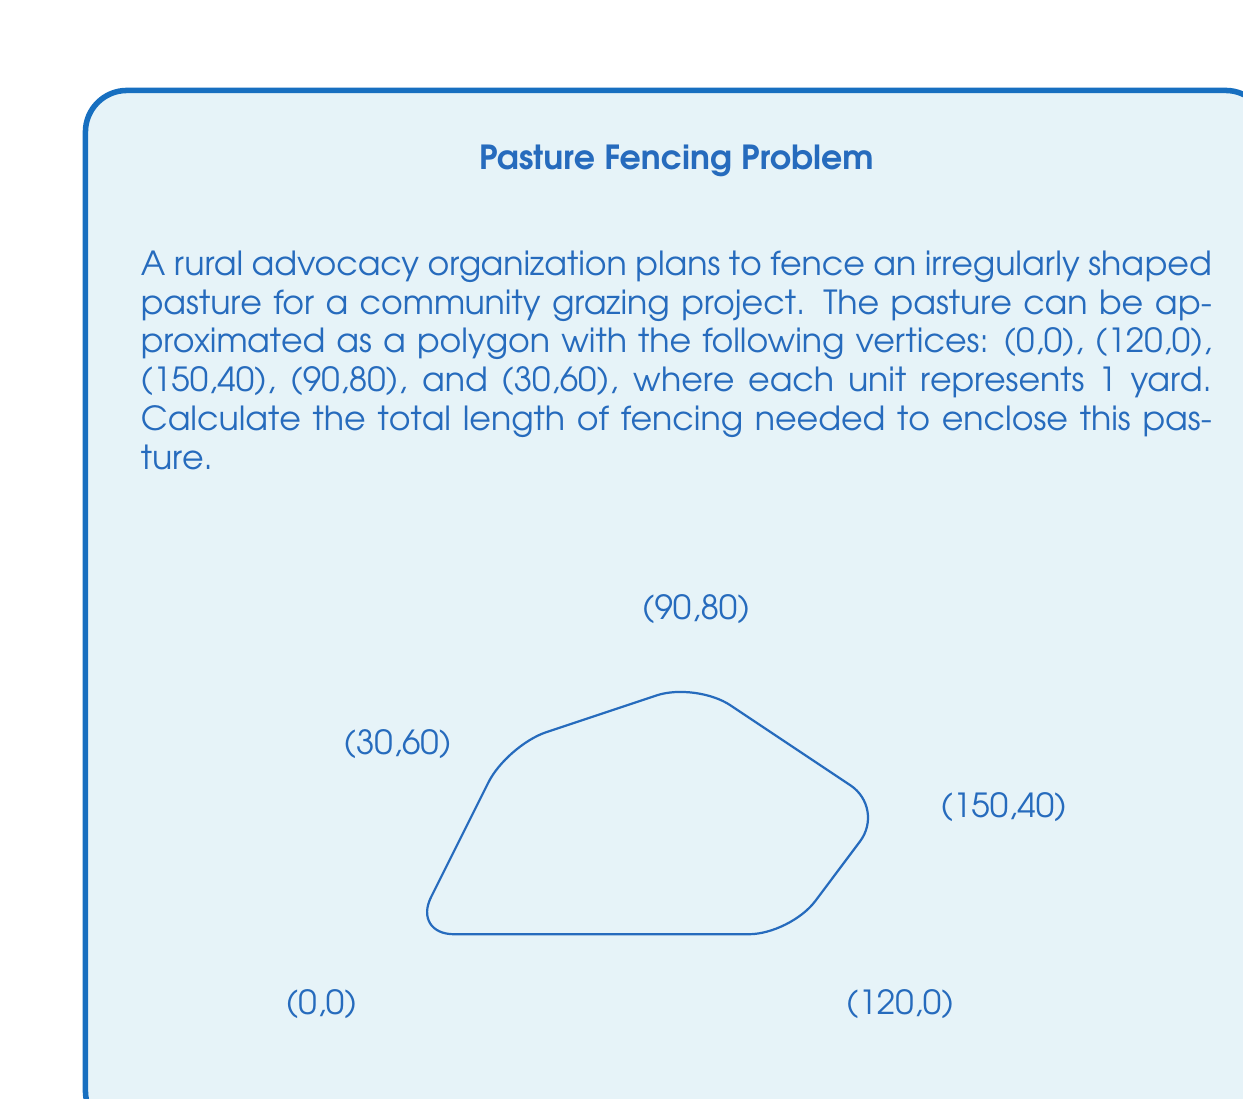Give your solution to this math problem. To solve this problem, we need to calculate the distance between each pair of consecutive vertices and sum these distances. We can use the distance formula between two points $(x_1, y_1)$ and $(x_2, y_2)$:

$$d = \sqrt{(x_2-x_1)^2 + (y_2-y_1)^2}$$

Let's calculate the length of each side:

1. Side 1 (from (0,0) to (120,0)):
   $$d_1 = \sqrt{(120-0)^2 + (0-0)^2} = 120$$

2. Side 2 (from (120,0) to (150,40)):
   $$d_2 = \sqrt{(150-120)^2 + (40-0)^2} = \sqrt{30^2 + 40^2} = 50$$

3. Side 3 (from (150,40) to (90,80)):
   $$d_3 = \sqrt{(90-150)^2 + (80-40)^2} = \sqrt{60^2 + 40^2} = \sqrt{5200} \approx 72.11$$

4. Side 4 (from (90,80) to (30,60)):
   $$d_4 = \sqrt{(30-90)^2 + (60-80)^2} = \sqrt{60^2 + 20^2} = \sqrt{4000} \approx 63.25$$

5. Side 5 (from (30,60) to (0,0)):
   $$d_5 = \sqrt{(0-30)^2 + (0-60)^2} = \sqrt{900 + 3600} = \sqrt{4500} \approx 67.08$$

Now, we sum all these distances:

$$\text{Total length} = d_1 + d_2 + d_3 + d_4 + d_5$$
$$\text{Total length} = 120 + 50 + 72.11 + 63.25 + 67.08 = 372.44 \text{ yards}$$

Rounding to the nearest yard, we get 372 yards.
Answer: The total length of fencing needed is approximately 372 yards. 